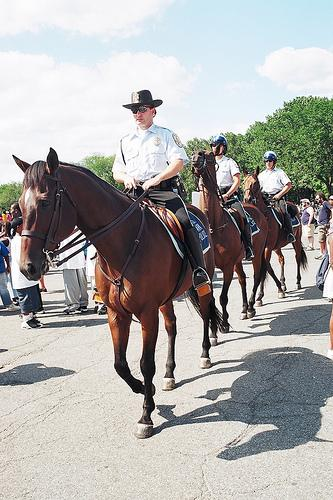Analyze the sentiment conveyed by the image based on the image. The image conveys a sense of security and order as police officers ride their horses, while spectators, including a child, watch the scene. In a sentence, narrate the atmosphere created by the presence of vibrant green trees. The presence of vibrant green trees in the background creates a calm and relaxing atmosphere amidst the scene of policemen riding horses. What is the primary focus of this image and what actions are taking place? The primary focus is on the policemen riding horses, with one of them wearing a wide-brimmed black hat and sunglasses, and a child watching them in the crowd. Count the total number of horses, riders, and individuals wearing a cap or hat mentioned in the image. There are three horses, three riders, and two individuals wearing a cap or a hat. What objects or features are associated with the spectators in the image? A man on white shirt, grey pants, child wearing baggy jean pants, and a person in the crowd wearing a cap are features associated with the spectators. Describe the attire of the child watching the policemen ride the horses. The child watching the policemen is wearing a white t-shirt, blue jean shorts, a black and white sneakers, and has a shadow on the ground. Examine the horse in the front and list any object interactions it has with other objects or characters in the image. The horse in the front interacts with its rider, who is an officer with sunglasses, and has his feet in the stirrups. It also has a saddle and a strap around it. Based on the given image information, describe the scene's overall quality and composition. The scene has a well-balanced composition with a clear focus on police officers riding horses, along with interesting details like shadows and lively green trees surrounding spectators. Mention any noticeable details about the horse in the front. The horse in the front has black ears, a black harness, and a bridle. It also has a strap around it, and gray color on its foot. List all the attributes related to one of the horses and its rider. The attributes of the horse in the middle and its rider include cracked line in the sidewalk, lapel on the side of the shirt, the wide brimmed black hat, and the officer wearing the helmet. Can you detect an event taking place in the image with officers and horses? Yes, there is a parade or procession with policemen riding horses. Explain the background of the image. The background consists of vibrant green trees and also includes horses and officers. Determine the emotions displayed by the people in the image. The people in the image, including the child and officers, appear focused and engaged in the event. Describe the attire of the officer in the middle. The officer in the middle is wearing a helmet and possibly a white shirt. What are the two things that the child is observing? The child is watching the policemen ride horses and also has his shadow on the ground. Zoom in on the ice cream cone that seems to be melting in the hands of a spectator, near the grey pants. No, it's not mentioned in the image. Describe the horse's facial features. The face of the horse in the front has black hair, two black ears, and the eye is visible. Examine the presence of any charts or graphs within the image. There are no charts or graphs present in the image. Describe the features of the sidewalk in the image. The sidewalk has a cracked line and is the surface where the horse is walking on. Create a short story involving the people and animals in the image. In a small town parade, three policemen rode their mighty horses gracefully. A young boy in casual attire watched in awe as these beautiful creatures moved down the street, accompanied by the shadows of the horses on the pavement. What is the activity taking place involving the officers? The activity is officers riding horses. What type of hat is the officer wearing? The officer is wearing a wide-brimmed black hat or helmet. What is the role of the man in the crowd? The man in the crowd is a spectator wearing a cap. Analyze the presence of any diagrams within the image. There are no diagrams present in the image. What can you see the horses wearing as headgear? The horses are wearing bridles and harnesses. Identify the attire of the policeman in the front. The policeman in the front is wearing a helmet, sunglasses, and a white shirt. Identify the types of clothing being worn by the boy in the image. The boy is wearing baggy jean pants, black and white sneakers, blue jean shorts, and a white t-shirt. Create a poem inspired by the image. In the town's parade so bright, Which of the following is NOT depicted on the horse: a) black strap b) gray color on foot c) purple spots? purple spots 